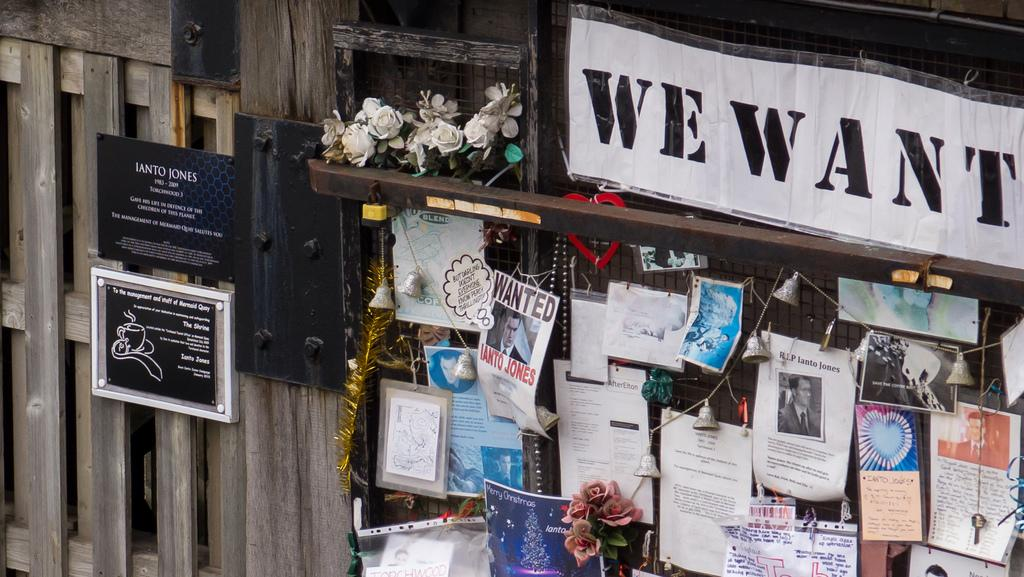What is in the center of the image? There is a fence in the center of the image. What is placed on the fence? Papers, decors, flowers, and boards are placed on the fence. Can you describe the decorations on the fence? The decorations on the fence include flowers and other unspecified decors. How many brothers are visible on the fence in the image? There are no brothers present in the image; it features a fence with papers, decors, flowers, and boards. 